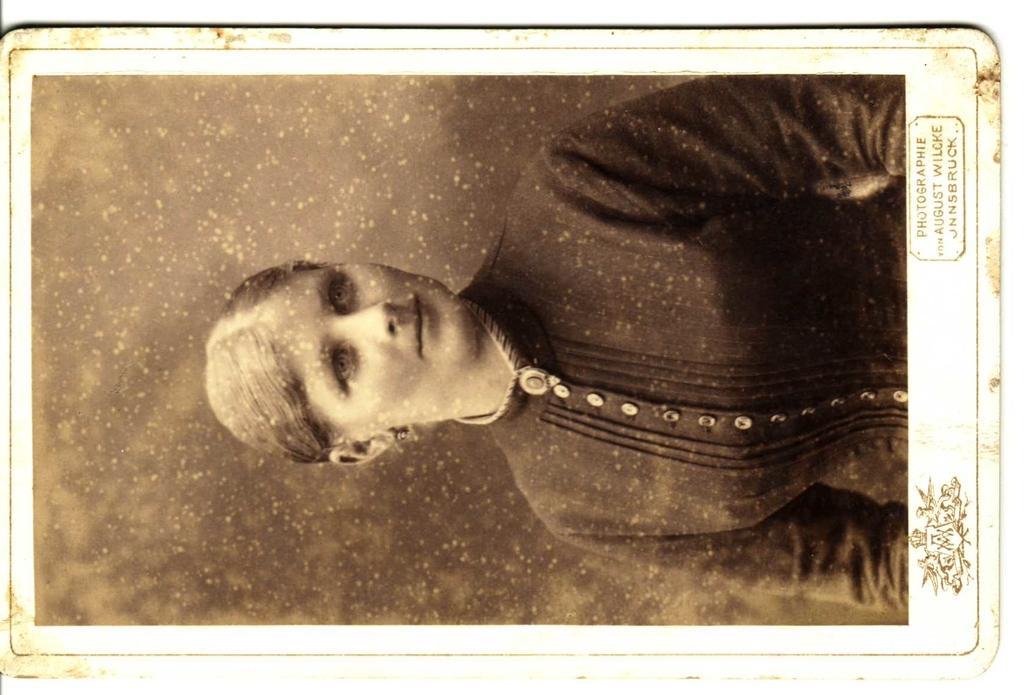How would you summarize this image in a sentence or two? In this image we can see a black and white picture of a woman wearing dress. In the bottom we can see some text and a logo. 